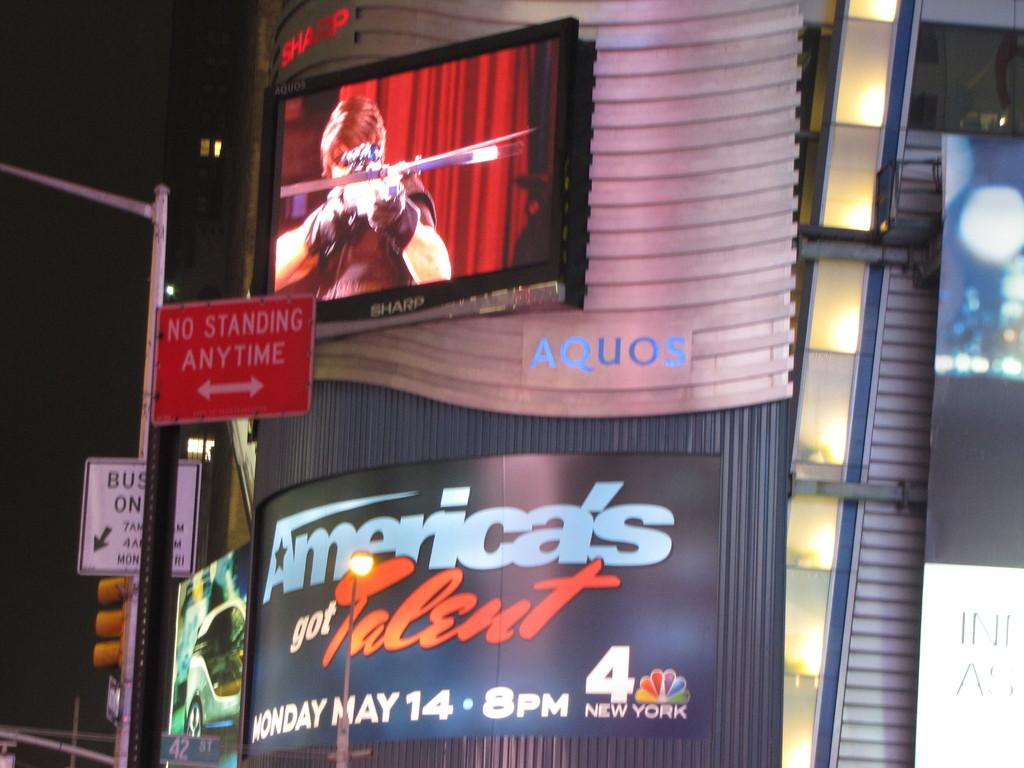<image>
Give a short and clear explanation of the subsequent image. Below a television screen showing a person shooting a cross bow, is an advertisement for the date and time of the next episode of America's Got Talent. 